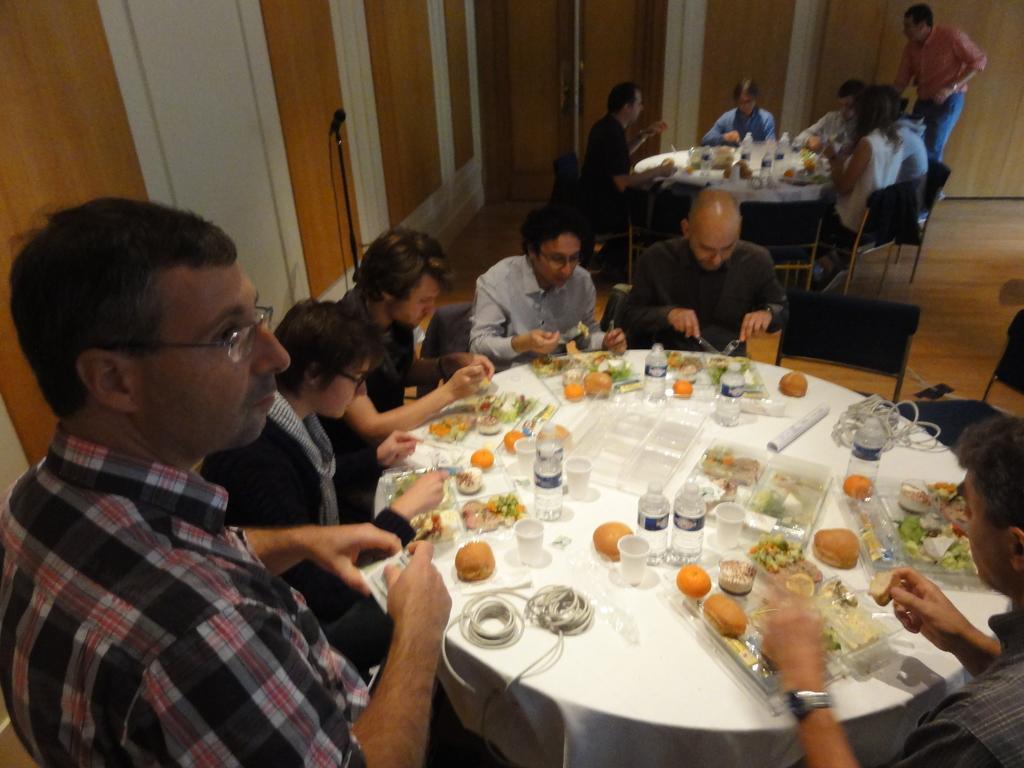Please provide a concise description of this image. Few persons are sitting on the chairs and few persons are standing. We can see boxes,bottles,cups,fruits,spoons,cables and food on the tables. This is floor. On the background we can see wall. 